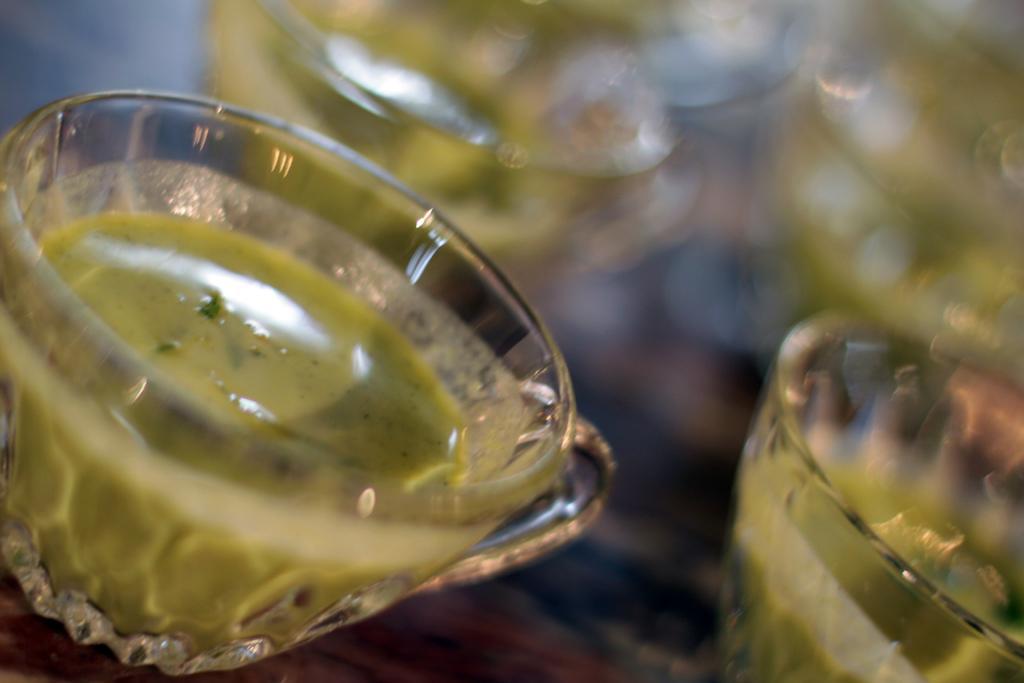Describe this image in one or two sentences. In this image there are cups, there is a cup truncated towards the right of the image, there is a cup truncated towards the left of the image, there is a drink in the cup, the background of the image is blurred. 